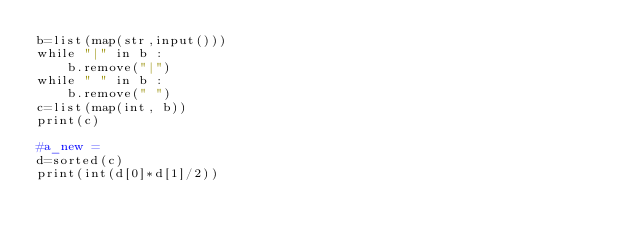Convert code to text. <code><loc_0><loc_0><loc_500><loc_500><_Python_>b=list(map(str,input()))
while "|" in b :
    b.remove("|")
while " " in b :
    b.remove(" ")
c=list(map(int, b))
print(c)

#a_new =
d=sorted(c)
print(int(d[0]*d[1]/2))</code> 